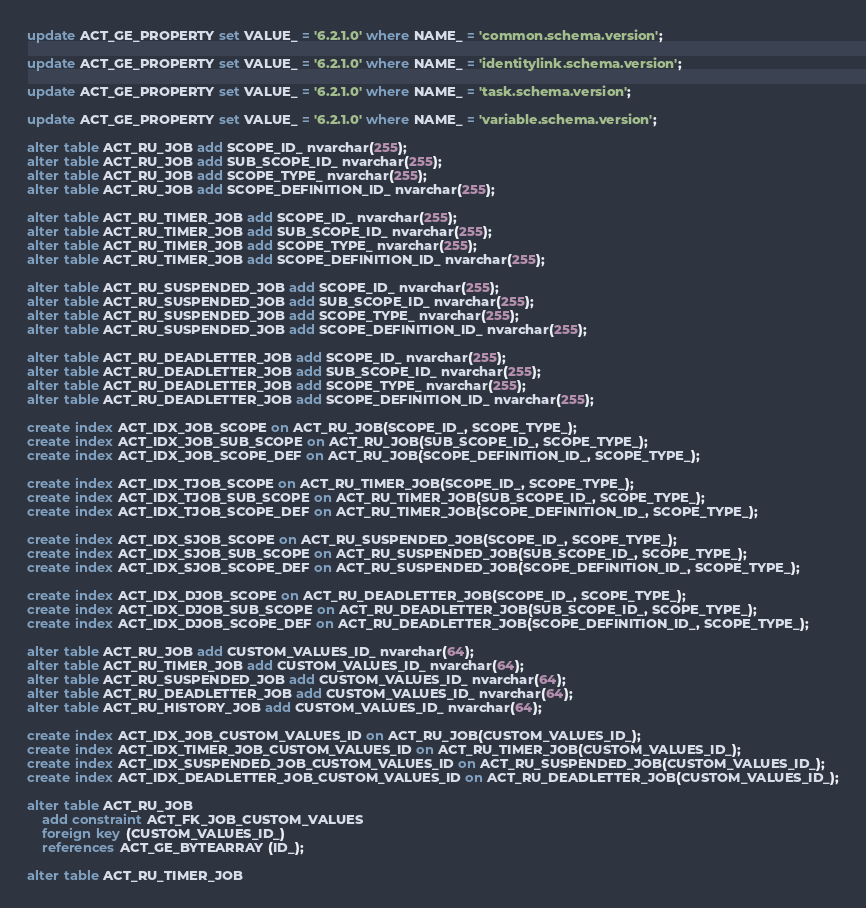Convert code to text. <code><loc_0><loc_0><loc_500><loc_500><_SQL_>update ACT_GE_PROPERTY set VALUE_ = '6.2.1.0' where NAME_ = 'common.schema.version';

update ACT_GE_PROPERTY set VALUE_ = '6.2.1.0' where NAME_ = 'identitylink.schema.version';

update ACT_GE_PROPERTY set VALUE_ = '6.2.1.0' where NAME_ = 'task.schema.version';

update ACT_GE_PROPERTY set VALUE_ = '6.2.1.0' where NAME_ = 'variable.schema.version';

alter table ACT_RU_JOB add SCOPE_ID_ nvarchar(255);
alter table ACT_RU_JOB add SUB_SCOPE_ID_ nvarchar(255);
alter table ACT_RU_JOB add SCOPE_TYPE_ nvarchar(255);
alter table ACT_RU_JOB add SCOPE_DEFINITION_ID_ nvarchar(255);

alter table ACT_RU_TIMER_JOB add SCOPE_ID_ nvarchar(255);
alter table ACT_RU_TIMER_JOB add SUB_SCOPE_ID_ nvarchar(255);
alter table ACT_RU_TIMER_JOB add SCOPE_TYPE_ nvarchar(255);
alter table ACT_RU_TIMER_JOB add SCOPE_DEFINITION_ID_ nvarchar(255);

alter table ACT_RU_SUSPENDED_JOB add SCOPE_ID_ nvarchar(255);
alter table ACT_RU_SUSPENDED_JOB add SUB_SCOPE_ID_ nvarchar(255);
alter table ACT_RU_SUSPENDED_JOB add SCOPE_TYPE_ nvarchar(255);
alter table ACT_RU_SUSPENDED_JOB add SCOPE_DEFINITION_ID_ nvarchar(255);

alter table ACT_RU_DEADLETTER_JOB add SCOPE_ID_ nvarchar(255);
alter table ACT_RU_DEADLETTER_JOB add SUB_SCOPE_ID_ nvarchar(255);
alter table ACT_RU_DEADLETTER_JOB add SCOPE_TYPE_ nvarchar(255);
alter table ACT_RU_DEADLETTER_JOB add SCOPE_DEFINITION_ID_ nvarchar(255);

create index ACT_IDX_JOB_SCOPE on ACT_RU_JOB(SCOPE_ID_, SCOPE_TYPE_);
create index ACT_IDX_JOB_SUB_SCOPE on ACT_RU_JOB(SUB_SCOPE_ID_, SCOPE_TYPE_);
create index ACT_IDX_JOB_SCOPE_DEF on ACT_RU_JOB(SCOPE_DEFINITION_ID_, SCOPE_TYPE_);

create index ACT_IDX_TJOB_SCOPE on ACT_RU_TIMER_JOB(SCOPE_ID_, SCOPE_TYPE_);
create index ACT_IDX_TJOB_SUB_SCOPE on ACT_RU_TIMER_JOB(SUB_SCOPE_ID_, SCOPE_TYPE_);
create index ACT_IDX_TJOB_SCOPE_DEF on ACT_RU_TIMER_JOB(SCOPE_DEFINITION_ID_, SCOPE_TYPE_); 

create index ACT_IDX_SJOB_SCOPE on ACT_RU_SUSPENDED_JOB(SCOPE_ID_, SCOPE_TYPE_);
create index ACT_IDX_SJOB_SUB_SCOPE on ACT_RU_SUSPENDED_JOB(SUB_SCOPE_ID_, SCOPE_TYPE_);
create index ACT_IDX_SJOB_SCOPE_DEF on ACT_RU_SUSPENDED_JOB(SCOPE_DEFINITION_ID_, SCOPE_TYPE_);   

create index ACT_IDX_DJOB_SCOPE on ACT_RU_DEADLETTER_JOB(SCOPE_ID_, SCOPE_TYPE_);
create index ACT_IDX_DJOB_SUB_SCOPE on ACT_RU_DEADLETTER_JOB(SUB_SCOPE_ID_, SCOPE_TYPE_);
create index ACT_IDX_DJOB_SCOPE_DEF on ACT_RU_DEADLETTER_JOB(SCOPE_DEFINITION_ID_, SCOPE_TYPE_); 

alter table ACT_RU_JOB add CUSTOM_VALUES_ID_ nvarchar(64);
alter table ACT_RU_TIMER_JOB add CUSTOM_VALUES_ID_ nvarchar(64);
alter table ACT_RU_SUSPENDED_JOB add CUSTOM_VALUES_ID_ nvarchar(64);
alter table ACT_RU_DEADLETTER_JOB add CUSTOM_VALUES_ID_ nvarchar(64);
alter table ACT_RU_HISTORY_JOB add CUSTOM_VALUES_ID_ nvarchar(64);

create index ACT_IDX_JOB_CUSTOM_VALUES_ID on ACT_RU_JOB(CUSTOM_VALUES_ID_);
create index ACT_IDX_TIMER_JOB_CUSTOM_VALUES_ID on ACT_RU_TIMER_JOB(CUSTOM_VALUES_ID_);
create index ACT_IDX_SUSPENDED_JOB_CUSTOM_VALUES_ID on ACT_RU_SUSPENDED_JOB(CUSTOM_VALUES_ID_);
create index ACT_IDX_DEADLETTER_JOB_CUSTOM_VALUES_ID on ACT_RU_DEADLETTER_JOB(CUSTOM_VALUES_ID_);

alter table ACT_RU_JOB
    add constraint ACT_FK_JOB_CUSTOM_VALUES
    foreign key (CUSTOM_VALUES_ID_)
    references ACT_GE_BYTEARRAY (ID_);

alter table ACT_RU_TIMER_JOB</code> 